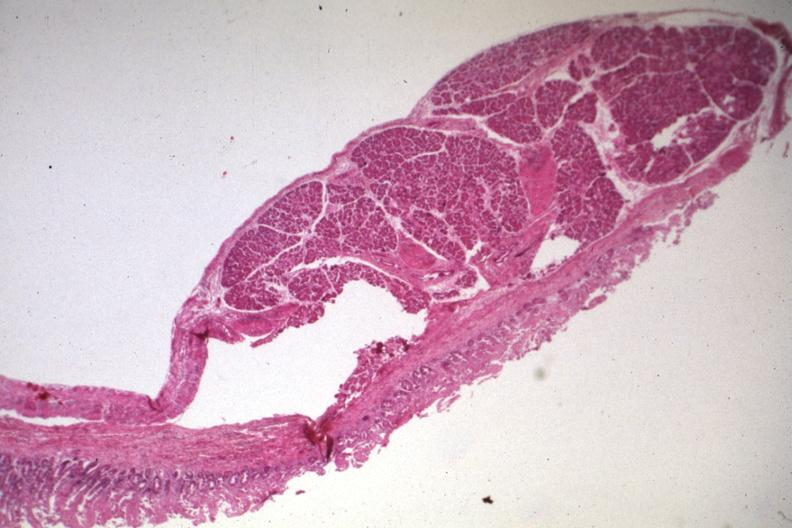s jejunum present?
Answer the question using a single word or phrase. Yes 